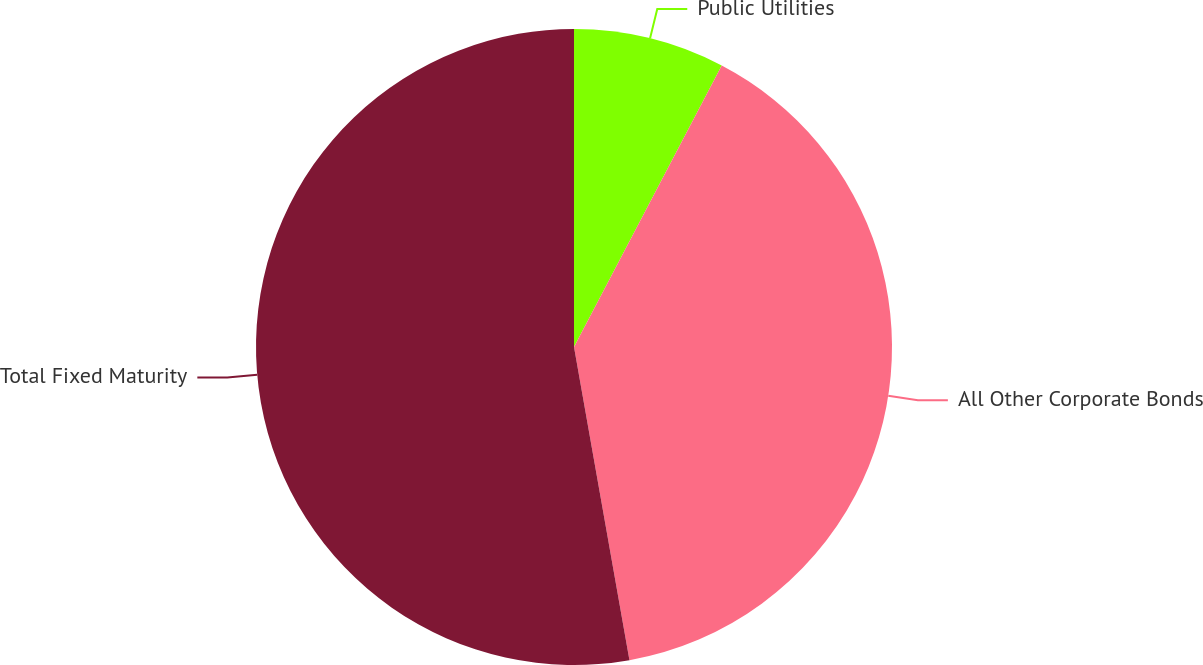Convert chart. <chart><loc_0><loc_0><loc_500><loc_500><pie_chart><fcel>Public Utilities<fcel>All Other Corporate Bonds<fcel>Total Fixed Maturity<nl><fcel>7.69%<fcel>39.52%<fcel>52.79%<nl></chart> 